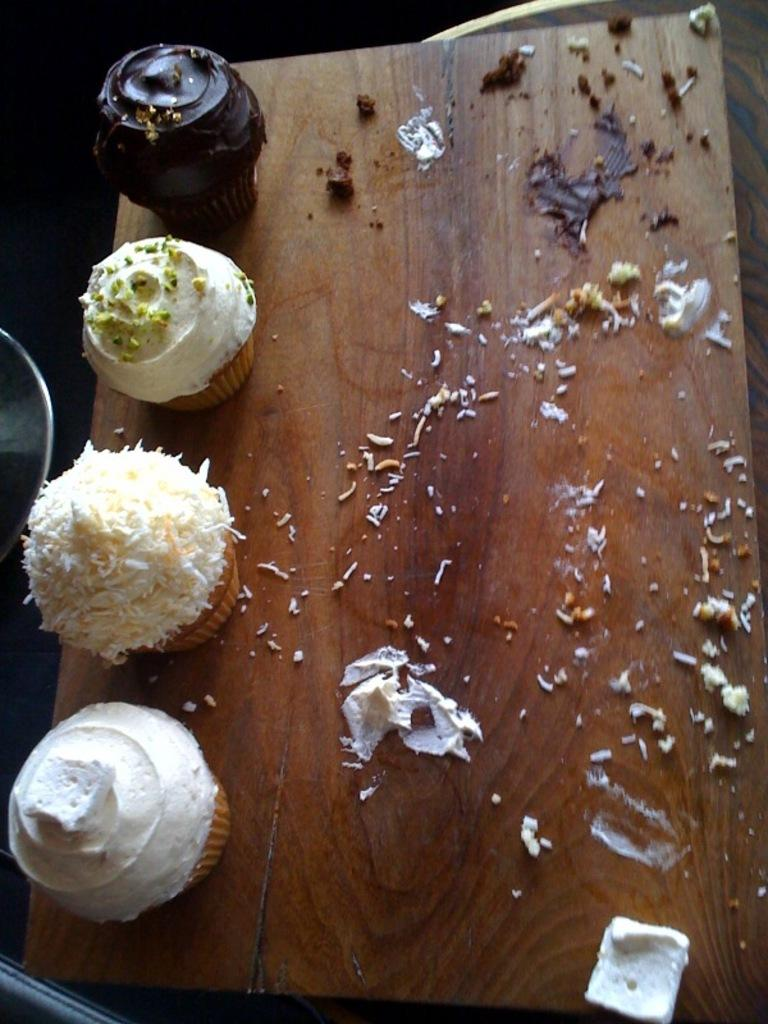What type of food can be seen in the image? There are muffins in the image. Where are the muffins placed? The muffins are on a wooden plank. What type of tent can be seen in the image? There is no tent present in the image; it features muffins on a wooden plank. How does the grandfather feel about the muffins in the image? There is no information about a grandfather or his feelings in the image. 